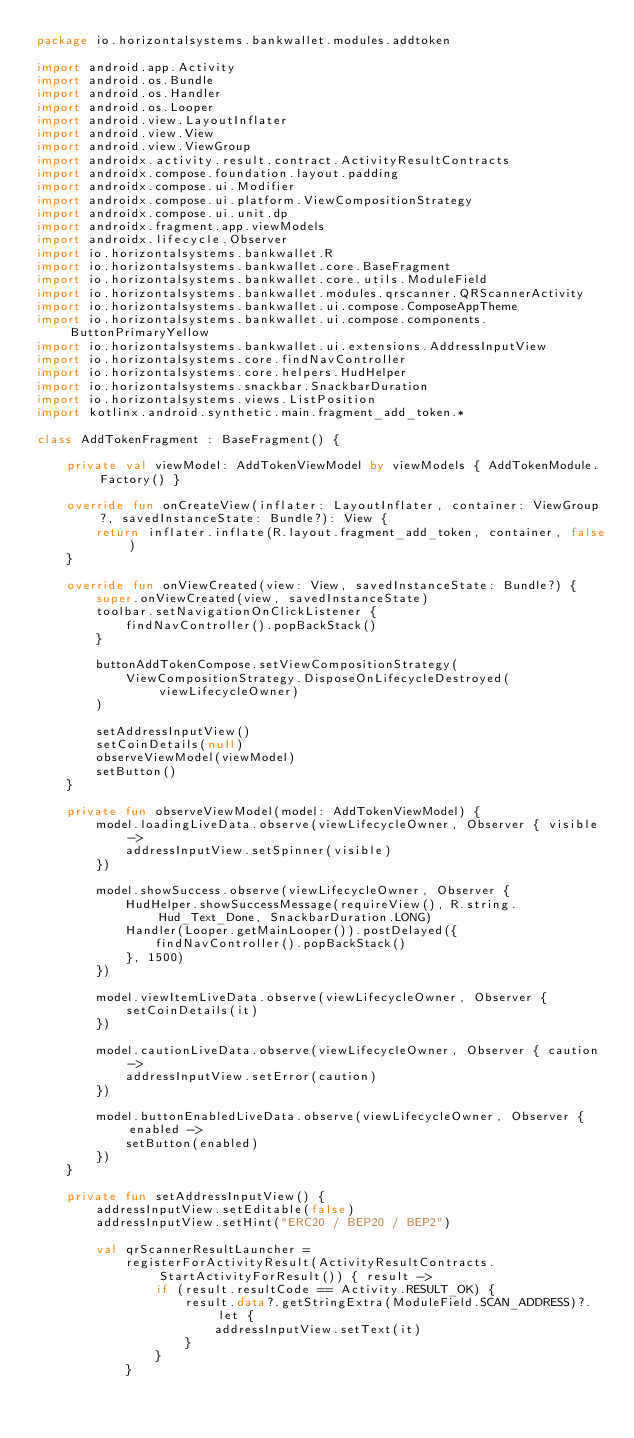<code> <loc_0><loc_0><loc_500><loc_500><_Kotlin_>package io.horizontalsystems.bankwallet.modules.addtoken

import android.app.Activity
import android.os.Bundle
import android.os.Handler
import android.os.Looper
import android.view.LayoutInflater
import android.view.View
import android.view.ViewGroup
import androidx.activity.result.contract.ActivityResultContracts
import androidx.compose.foundation.layout.padding
import androidx.compose.ui.Modifier
import androidx.compose.ui.platform.ViewCompositionStrategy
import androidx.compose.ui.unit.dp
import androidx.fragment.app.viewModels
import androidx.lifecycle.Observer
import io.horizontalsystems.bankwallet.R
import io.horizontalsystems.bankwallet.core.BaseFragment
import io.horizontalsystems.bankwallet.core.utils.ModuleField
import io.horizontalsystems.bankwallet.modules.qrscanner.QRScannerActivity
import io.horizontalsystems.bankwallet.ui.compose.ComposeAppTheme
import io.horizontalsystems.bankwallet.ui.compose.components.ButtonPrimaryYellow
import io.horizontalsystems.bankwallet.ui.extensions.AddressInputView
import io.horizontalsystems.core.findNavController
import io.horizontalsystems.core.helpers.HudHelper
import io.horizontalsystems.snackbar.SnackbarDuration
import io.horizontalsystems.views.ListPosition
import kotlinx.android.synthetic.main.fragment_add_token.*

class AddTokenFragment : BaseFragment() {

    private val viewModel: AddTokenViewModel by viewModels { AddTokenModule.Factory() }

    override fun onCreateView(inflater: LayoutInflater, container: ViewGroup?, savedInstanceState: Bundle?): View {
        return inflater.inflate(R.layout.fragment_add_token, container, false)
    }

    override fun onViewCreated(view: View, savedInstanceState: Bundle?) {
        super.onViewCreated(view, savedInstanceState)
        toolbar.setNavigationOnClickListener {
            findNavController().popBackStack()
        }

        buttonAddTokenCompose.setViewCompositionStrategy(
            ViewCompositionStrategy.DisposeOnLifecycleDestroyed(viewLifecycleOwner)
        )

        setAddressInputView()
        setCoinDetails(null)
        observeViewModel(viewModel)
        setButton()
    }

    private fun observeViewModel(model: AddTokenViewModel) {
        model.loadingLiveData.observe(viewLifecycleOwner, Observer { visible ->
            addressInputView.setSpinner(visible)
        })

        model.showSuccess.observe(viewLifecycleOwner, Observer {
            HudHelper.showSuccessMessage(requireView(), R.string.Hud_Text_Done, SnackbarDuration.LONG)
            Handler(Looper.getMainLooper()).postDelayed({
                findNavController().popBackStack()
            }, 1500)
        })

        model.viewItemLiveData.observe(viewLifecycleOwner, Observer {
            setCoinDetails(it)
        })

        model.cautionLiveData.observe(viewLifecycleOwner, Observer { caution ->
            addressInputView.setError(caution)
        })

        model.buttonEnabledLiveData.observe(viewLifecycleOwner, Observer { enabled ->
            setButton(enabled)
        })
    }

    private fun setAddressInputView() {
        addressInputView.setEditable(false)
        addressInputView.setHint("ERC20 / BEP20 / BEP2")

        val qrScannerResultLauncher =
            registerForActivityResult(ActivityResultContracts.StartActivityForResult()) { result ->
                if (result.resultCode == Activity.RESULT_OK) {
                    result.data?.getStringExtra(ModuleField.SCAN_ADDRESS)?.let {
                        addressInputView.setText(it)
                    }
                }
            }
</code> 